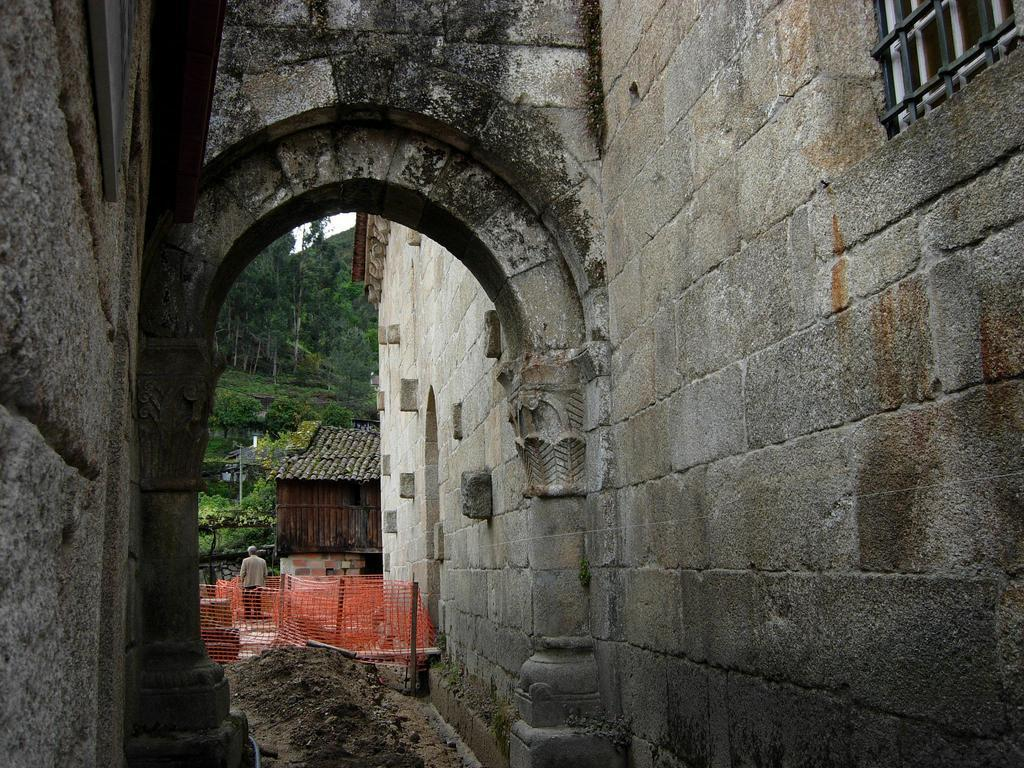What type of structure is visible in the image? There is a building in the image. How can someone enter the building? There is an entrance to the building. What is the color of the net in the image? The net in the image is orange. What can be seen in the background of the image? There is a house and trees in the background of the image. How does the door in the image prevent the car from moving forward? There is no car or door present in the image; it only features a building, an entrance, an orange net, a house, and trees in the background. 